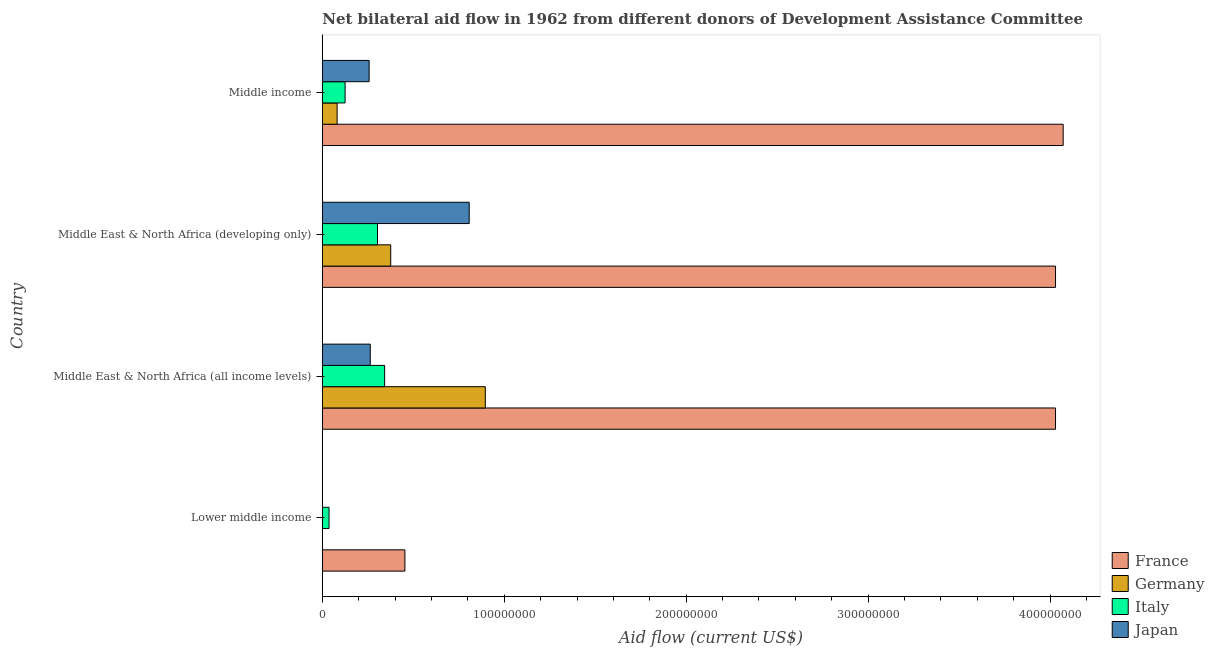How many groups of bars are there?
Keep it short and to the point. 4. Are the number of bars per tick equal to the number of legend labels?
Your answer should be very brief. No. What is the label of the 1st group of bars from the top?
Offer a very short reply. Middle income. In how many cases, is the number of bars for a given country not equal to the number of legend labels?
Make the answer very short. 1. What is the amount of aid given by italy in Lower middle income?
Offer a terse response. 3.69e+06. Across all countries, what is the maximum amount of aid given by germany?
Your response must be concise. 8.96e+07. Across all countries, what is the minimum amount of aid given by germany?
Your answer should be very brief. 8.00e+04. In which country was the amount of aid given by japan maximum?
Make the answer very short. Middle East & North Africa (developing only). What is the total amount of aid given by france in the graph?
Your response must be concise. 1.26e+09. What is the difference between the amount of aid given by germany in Lower middle income and that in Middle income?
Give a very brief answer. -8.05e+06. What is the difference between the amount of aid given by germany in Middle income and the amount of aid given by italy in Middle East & North Africa (all income levels)?
Provide a succinct answer. -2.61e+07. What is the average amount of aid given by france per country?
Make the answer very short. 3.15e+08. What is the difference between the amount of aid given by italy and amount of aid given by germany in Middle East & North Africa (developing only)?
Keep it short and to the point. -7.27e+06. What is the ratio of the amount of aid given by germany in Middle East & North Africa (developing only) to that in Middle income?
Provide a short and direct response. 4.62. Is the amount of aid given by japan in Middle East & North Africa (all income levels) less than that in Middle income?
Make the answer very short. No. What is the difference between the highest and the second highest amount of aid given by italy?
Your answer should be very brief. 3.92e+06. What is the difference between the highest and the lowest amount of aid given by france?
Ensure brevity in your answer.  3.62e+08. Is the sum of the amount of aid given by germany in Middle East & North Africa (all income levels) and Middle East & North Africa (developing only) greater than the maximum amount of aid given by france across all countries?
Provide a short and direct response. No. Is it the case that in every country, the sum of the amount of aid given by japan and amount of aid given by germany is greater than the sum of amount of aid given by france and amount of aid given by italy?
Your answer should be compact. No. Is it the case that in every country, the sum of the amount of aid given by france and amount of aid given by germany is greater than the amount of aid given by italy?
Make the answer very short. Yes. How many countries are there in the graph?
Offer a very short reply. 4. What is the difference between two consecutive major ticks on the X-axis?
Provide a short and direct response. 1.00e+08. Does the graph contain grids?
Make the answer very short. No. Where does the legend appear in the graph?
Ensure brevity in your answer.  Bottom right. How many legend labels are there?
Your answer should be compact. 4. What is the title of the graph?
Your answer should be compact. Net bilateral aid flow in 1962 from different donors of Development Assistance Committee. Does "Bird species" appear as one of the legend labels in the graph?
Offer a very short reply. No. What is the label or title of the X-axis?
Keep it short and to the point. Aid flow (current US$). What is the Aid flow (current US$) of France in Lower middle income?
Your answer should be very brief. 4.54e+07. What is the Aid flow (current US$) of Italy in Lower middle income?
Your answer should be compact. 3.69e+06. What is the Aid flow (current US$) in France in Middle East & North Africa (all income levels)?
Offer a terse response. 4.03e+08. What is the Aid flow (current US$) of Germany in Middle East & North Africa (all income levels)?
Your answer should be compact. 8.96e+07. What is the Aid flow (current US$) in Italy in Middle East & North Africa (all income levels)?
Keep it short and to the point. 3.42e+07. What is the Aid flow (current US$) in Japan in Middle East & North Africa (all income levels)?
Your answer should be very brief. 2.64e+07. What is the Aid flow (current US$) in France in Middle East & North Africa (developing only)?
Make the answer very short. 4.03e+08. What is the Aid flow (current US$) in Germany in Middle East & North Africa (developing only)?
Your response must be concise. 3.76e+07. What is the Aid flow (current US$) of Italy in Middle East & North Africa (developing only)?
Keep it short and to the point. 3.03e+07. What is the Aid flow (current US$) in Japan in Middle East & North Africa (developing only)?
Your answer should be compact. 8.07e+07. What is the Aid flow (current US$) of France in Middle income?
Your answer should be compact. 4.07e+08. What is the Aid flow (current US$) of Germany in Middle income?
Provide a short and direct response. 8.13e+06. What is the Aid flow (current US$) of Italy in Middle income?
Ensure brevity in your answer.  1.25e+07. What is the Aid flow (current US$) of Japan in Middle income?
Your answer should be compact. 2.57e+07. Across all countries, what is the maximum Aid flow (current US$) of France?
Keep it short and to the point. 4.07e+08. Across all countries, what is the maximum Aid flow (current US$) in Germany?
Your response must be concise. 8.96e+07. Across all countries, what is the maximum Aid flow (current US$) in Italy?
Offer a very short reply. 3.42e+07. Across all countries, what is the maximum Aid flow (current US$) of Japan?
Ensure brevity in your answer.  8.07e+07. Across all countries, what is the minimum Aid flow (current US$) in France?
Your response must be concise. 4.54e+07. Across all countries, what is the minimum Aid flow (current US$) in Italy?
Your answer should be very brief. 3.69e+06. What is the total Aid flow (current US$) of France in the graph?
Provide a short and direct response. 1.26e+09. What is the total Aid flow (current US$) in Germany in the graph?
Offer a very short reply. 1.35e+08. What is the total Aid flow (current US$) of Italy in the graph?
Your response must be concise. 8.08e+07. What is the total Aid flow (current US$) in Japan in the graph?
Provide a short and direct response. 1.33e+08. What is the difference between the Aid flow (current US$) in France in Lower middle income and that in Middle East & North Africa (all income levels)?
Ensure brevity in your answer.  -3.58e+08. What is the difference between the Aid flow (current US$) of Germany in Lower middle income and that in Middle East & North Africa (all income levels)?
Provide a succinct answer. -8.95e+07. What is the difference between the Aid flow (current US$) in Italy in Lower middle income and that in Middle East & North Africa (all income levels)?
Offer a terse response. -3.06e+07. What is the difference between the Aid flow (current US$) in France in Lower middle income and that in Middle East & North Africa (developing only)?
Provide a succinct answer. -3.58e+08. What is the difference between the Aid flow (current US$) in Germany in Lower middle income and that in Middle East & North Africa (developing only)?
Make the answer very short. -3.75e+07. What is the difference between the Aid flow (current US$) of Italy in Lower middle income and that in Middle East & North Africa (developing only)?
Ensure brevity in your answer.  -2.66e+07. What is the difference between the Aid flow (current US$) of France in Lower middle income and that in Middle income?
Give a very brief answer. -3.62e+08. What is the difference between the Aid flow (current US$) in Germany in Lower middle income and that in Middle income?
Ensure brevity in your answer.  -8.05e+06. What is the difference between the Aid flow (current US$) of Italy in Lower middle income and that in Middle income?
Give a very brief answer. -8.81e+06. What is the difference between the Aid flow (current US$) of Germany in Middle East & North Africa (all income levels) and that in Middle East & North Africa (developing only)?
Give a very brief answer. 5.20e+07. What is the difference between the Aid flow (current US$) in Italy in Middle East & North Africa (all income levels) and that in Middle East & North Africa (developing only)?
Ensure brevity in your answer.  3.92e+06. What is the difference between the Aid flow (current US$) of Japan in Middle East & North Africa (all income levels) and that in Middle East & North Africa (developing only)?
Your answer should be compact. -5.44e+07. What is the difference between the Aid flow (current US$) of France in Middle East & North Africa (all income levels) and that in Middle income?
Your answer should be very brief. -4.20e+06. What is the difference between the Aid flow (current US$) in Germany in Middle East & North Africa (all income levels) and that in Middle income?
Offer a very short reply. 8.14e+07. What is the difference between the Aid flow (current US$) of Italy in Middle East & North Africa (all income levels) and that in Middle income?
Offer a very short reply. 2.17e+07. What is the difference between the Aid flow (current US$) in Japan in Middle East & North Africa (all income levels) and that in Middle income?
Your answer should be very brief. 6.30e+05. What is the difference between the Aid flow (current US$) in France in Middle East & North Africa (developing only) and that in Middle income?
Offer a terse response. -4.20e+06. What is the difference between the Aid flow (current US$) in Germany in Middle East & North Africa (developing only) and that in Middle income?
Make the answer very short. 2.95e+07. What is the difference between the Aid flow (current US$) of Italy in Middle East & North Africa (developing only) and that in Middle income?
Give a very brief answer. 1.78e+07. What is the difference between the Aid flow (current US$) in Japan in Middle East & North Africa (developing only) and that in Middle income?
Provide a succinct answer. 5.50e+07. What is the difference between the Aid flow (current US$) of France in Lower middle income and the Aid flow (current US$) of Germany in Middle East & North Africa (all income levels)?
Provide a short and direct response. -4.42e+07. What is the difference between the Aid flow (current US$) of France in Lower middle income and the Aid flow (current US$) of Italy in Middle East & North Africa (all income levels)?
Offer a terse response. 1.12e+07. What is the difference between the Aid flow (current US$) of France in Lower middle income and the Aid flow (current US$) of Japan in Middle East & North Africa (all income levels)?
Keep it short and to the point. 1.90e+07. What is the difference between the Aid flow (current US$) in Germany in Lower middle income and the Aid flow (current US$) in Italy in Middle East & North Africa (all income levels)?
Keep it short and to the point. -3.42e+07. What is the difference between the Aid flow (current US$) of Germany in Lower middle income and the Aid flow (current US$) of Japan in Middle East & North Africa (all income levels)?
Provide a short and direct response. -2.63e+07. What is the difference between the Aid flow (current US$) of Italy in Lower middle income and the Aid flow (current US$) of Japan in Middle East & North Africa (all income levels)?
Keep it short and to the point. -2.27e+07. What is the difference between the Aid flow (current US$) of France in Lower middle income and the Aid flow (current US$) of Germany in Middle East & North Africa (developing only)?
Keep it short and to the point. 7.81e+06. What is the difference between the Aid flow (current US$) in France in Lower middle income and the Aid flow (current US$) in Italy in Middle East & North Africa (developing only)?
Offer a very short reply. 1.51e+07. What is the difference between the Aid flow (current US$) in France in Lower middle income and the Aid flow (current US$) in Japan in Middle East & North Africa (developing only)?
Your response must be concise. -3.53e+07. What is the difference between the Aid flow (current US$) of Germany in Lower middle income and the Aid flow (current US$) of Italy in Middle East & North Africa (developing only)?
Ensure brevity in your answer.  -3.02e+07. What is the difference between the Aid flow (current US$) of Germany in Lower middle income and the Aid flow (current US$) of Japan in Middle East & North Africa (developing only)?
Make the answer very short. -8.06e+07. What is the difference between the Aid flow (current US$) in Italy in Lower middle income and the Aid flow (current US$) in Japan in Middle East & North Africa (developing only)?
Ensure brevity in your answer.  -7.70e+07. What is the difference between the Aid flow (current US$) of France in Lower middle income and the Aid flow (current US$) of Germany in Middle income?
Provide a succinct answer. 3.73e+07. What is the difference between the Aid flow (current US$) of France in Lower middle income and the Aid flow (current US$) of Italy in Middle income?
Give a very brief answer. 3.29e+07. What is the difference between the Aid flow (current US$) of France in Lower middle income and the Aid flow (current US$) of Japan in Middle income?
Offer a terse response. 1.97e+07. What is the difference between the Aid flow (current US$) of Germany in Lower middle income and the Aid flow (current US$) of Italy in Middle income?
Keep it short and to the point. -1.24e+07. What is the difference between the Aid flow (current US$) of Germany in Lower middle income and the Aid flow (current US$) of Japan in Middle income?
Your answer should be compact. -2.56e+07. What is the difference between the Aid flow (current US$) in Italy in Lower middle income and the Aid flow (current US$) in Japan in Middle income?
Offer a very short reply. -2.20e+07. What is the difference between the Aid flow (current US$) of France in Middle East & North Africa (all income levels) and the Aid flow (current US$) of Germany in Middle East & North Africa (developing only)?
Keep it short and to the point. 3.65e+08. What is the difference between the Aid flow (current US$) of France in Middle East & North Africa (all income levels) and the Aid flow (current US$) of Italy in Middle East & North Africa (developing only)?
Provide a short and direct response. 3.73e+08. What is the difference between the Aid flow (current US$) in France in Middle East & North Africa (all income levels) and the Aid flow (current US$) in Japan in Middle East & North Africa (developing only)?
Give a very brief answer. 3.22e+08. What is the difference between the Aid flow (current US$) of Germany in Middle East & North Africa (all income levels) and the Aid flow (current US$) of Italy in Middle East & North Africa (developing only)?
Offer a very short reply. 5.93e+07. What is the difference between the Aid flow (current US$) of Germany in Middle East & North Africa (all income levels) and the Aid flow (current US$) of Japan in Middle East & North Africa (developing only)?
Make the answer very short. 8.85e+06. What is the difference between the Aid flow (current US$) of Italy in Middle East & North Africa (all income levels) and the Aid flow (current US$) of Japan in Middle East & North Africa (developing only)?
Your response must be concise. -4.65e+07. What is the difference between the Aid flow (current US$) of France in Middle East & North Africa (all income levels) and the Aid flow (current US$) of Germany in Middle income?
Give a very brief answer. 3.95e+08. What is the difference between the Aid flow (current US$) of France in Middle East & North Africa (all income levels) and the Aid flow (current US$) of Italy in Middle income?
Your answer should be compact. 3.90e+08. What is the difference between the Aid flow (current US$) of France in Middle East & North Africa (all income levels) and the Aid flow (current US$) of Japan in Middle income?
Keep it short and to the point. 3.77e+08. What is the difference between the Aid flow (current US$) of Germany in Middle East & North Africa (all income levels) and the Aid flow (current US$) of Italy in Middle income?
Keep it short and to the point. 7.71e+07. What is the difference between the Aid flow (current US$) of Germany in Middle East & North Africa (all income levels) and the Aid flow (current US$) of Japan in Middle income?
Provide a succinct answer. 6.39e+07. What is the difference between the Aid flow (current US$) in Italy in Middle East & North Africa (all income levels) and the Aid flow (current US$) in Japan in Middle income?
Your response must be concise. 8.52e+06. What is the difference between the Aid flow (current US$) of France in Middle East & North Africa (developing only) and the Aid flow (current US$) of Germany in Middle income?
Provide a short and direct response. 3.95e+08. What is the difference between the Aid flow (current US$) in France in Middle East & North Africa (developing only) and the Aid flow (current US$) in Italy in Middle income?
Offer a terse response. 3.90e+08. What is the difference between the Aid flow (current US$) of France in Middle East & North Africa (developing only) and the Aid flow (current US$) of Japan in Middle income?
Your answer should be compact. 3.77e+08. What is the difference between the Aid flow (current US$) in Germany in Middle East & North Africa (developing only) and the Aid flow (current US$) in Italy in Middle income?
Provide a short and direct response. 2.51e+07. What is the difference between the Aid flow (current US$) of Germany in Middle East & North Africa (developing only) and the Aid flow (current US$) of Japan in Middle income?
Provide a succinct answer. 1.19e+07. What is the difference between the Aid flow (current US$) in Italy in Middle East & North Africa (developing only) and the Aid flow (current US$) in Japan in Middle income?
Give a very brief answer. 4.60e+06. What is the average Aid flow (current US$) of France per country?
Offer a very short reply. 3.15e+08. What is the average Aid flow (current US$) in Germany per country?
Keep it short and to the point. 3.38e+07. What is the average Aid flow (current US$) of Italy per country?
Your answer should be compact. 2.02e+07. What is the average Aid flow (current US$) of Japan per country?
Your answer should be compact. 3.32e+07. What is the difference between the Aid flow (current US$) of France and Aid flow (current US$) of Germany in Lower middle income?
Make the answer very short. 4.53e+07. What is the difference between the Aid flow (current US$) in France and Aid flow (current US$) in Italy in Lower middle income?
Provide a short and direct response. 4.17e+07. What is the difference between the Aid flow (current US$) of Germany and Aid flow (current US$) of Italy in Lower middle income?
Make the answer very short. -3.61e+06. What is the difference between the Aid flow (current US$) in France and Aid flow (current US$) in Germany in Middle East & North Africa (all income levels)?
Keep it short and to the point. 3.13e+08. What is the difference between the Aid flow (current US$) in France and Aid flow (current US$) in Italy in Middle East & North Africa (all income levels)?
Offer a very short reply. 3.69e+08. What is the difference between the Aid flow (current US$) in France and Aid flow (current US$) in Japan in Middle East & North Africa (all income levels)?
Provide a short and direct response. 3.77e+08. What is the difference between the Aid flow (current US$) of Germany and Aid flow (current US$) of Italy in Middle East & North Africa (all income levels)?
Your answer should be very brief. 5.53e+07. What is the difference between the Aid flow (current US$) of Germany and Aid flow (current US$) of Japan in Middle East & North Africa (all income levels)?
Your answer should be very brief. 6.32e+07. What is the difference between the Aid flow (current US$) of Italy and Aid flow (current US$) of Japan in Middle East & North Africa (all income levels)?
Your answer should be very brief. 7.89e+06. What is the difference between the Aid flow (current US$) in France and Aid flow (current US$) in Germany in Middle East & North Africa (developing only)?
Give a very brief answer. 3.65e+08. What is the difference between the Aid flow (current US$) of France and Aid flow (current US$) of Italy in Middle East & North Africa (developing only)?
Provide a succinct answer. 3.73e+08. What is the difference between the Aid flow (current US$) in France and Aid flow (current US$) in Japan in Middle East & North Africa (developing only)?
Give a very brief answer. 3.22e+08. What is the difference between the Aid flow (current US$) of Germany and Aid flow (current US$) of Italy in Middle East & North Africa (developing only)?
Offer a very short reply. 7.27e+06. What is the difference between the Aid flow (current US$) in Germany and Aid flow (current US$) in Japan in Middle East & North Africa (developing only)?
Ensure brevity in your answer.  -4.31e+07. What is the difference between the Aid flow (current US$) of Italy and Aid flow (current US$) of Japan in Middle East & North Africa (developing only)?
Ensure brevity in your answer.  -5.04e+07. What is the difference between the Aid flow (current US$) in France and Aid flow (current US$) in Germany in Middle income?
Ensure brevity in your answer.  3.99e+08. What is the difference between the Aid flow (current US$) of France and Aid flow (current US$) of Italy in Middle income?
Your answer should be very brief. 3.95e+08. What is the difference between the Aid flow (current US$) of France and Aid flow (current US$) of Japan in Middle income?
Your answer should be compact. 3.81e+08. What is the difference between the Aid flow (current US$) in Germany and Aid flow (current US$) in Italy in Middle income?
Make the answer very short. -4.37e+06. What is the difference between the Aid flow (current US$) in Germany and Aid flow (current US$) in Japan in Middle income?
Keep it short and to the point. -1.76e+07. What is the difference between the Aid flow (current US$) of Italy and Aid flow (current US$) of Japan in Middle income?
Give a very brief answer. -1.32e+07. What is the ratio of the Aid flow (current US$) of France in Lower middle income to that in Middle East & North Africa (all income levels)?
Offer a terse response. 0.11. What is the ratio of the Aid flow (current US$) of Germany in Lower middle income to that in Middle East & North Africa (all income levels)?
Provide a short and direct response. 0. What is the ratio of the Aid flow (current US$) in Italy in Lower middle income to that in Middle East & North Africa (all income levels)?
Offer a very short reply. 0.11. What is the ratio of the Aid flow (current US$) in France in Lower middle income to that in Middle East & North Africa (developing only)?
Make the answer very short. 0.11. What is the ratio of the Aid flow (current US$) of Germany in Lower middle income to that in Middle East & North Africa (developing only)?
Offer a very short reply. 0. What is the ratio of the Aid flow (current US$) in Italy in Lower middle income to that in Middle East & North Africa (developing only)?
Provide a succinct answer. 0.12. What is the ratio of the Aid flow (current US$) in France in Lower middle income to that in Middle income?
Provide a short and direct response. 0.11. What is the ratio of the Aid flow (current US$) of Germany in Lower middle income to that in Middle income?
Your answer should be compact. 0.01. What is the ratio of the Aid flow (current US$) of Italy in Lower middle income to that in Middle income?
Your answer should be compact. 0.3. What is the ratio of the Aid flow (current US$) of Germany in Middle East & North Africa (all income levels) to that in Middle East & North Africa (developing only)?
Make the answer very short. 2.38. What is the ratio of the Aid flow (current US$) in Italy in Middle East & North Africa (all income levels) to that in Middle East & North Africa (developing only)?
Ensure brevity in your answer.  1.13. What is the ratio of the Aid flow (current US$) in Japan in Middle East & North Africa (all income levels) to that in Middle East & North Africa (developing only)?
Keep it short and to the point. 0.33. What is the ratio of the Aid flow (current US$) of Germany in Middle East & North Africa (all income levels) to that in Middle income?
Ensure brevity in your answer.  11.02. What is the ratio of the Aid flow (current US$) in Italy in Middle East & North Africa (all income levels) to that in Middle income?
Your answer should be compact. 2.74. What is the ratio of the Aid flow (current US$) in Japan in Middle East & North Africa (all income levels) to that in Middle income?
Provide a short and direct response. 1.02. What is the ratio of the Aid flow (current US$) of France in Middle East & North Africa (developing only) to that in Middle income?
Keep it short and to the point. 0.99. What is the ratio of the Aid flow (current US$) in Germany in Middle East & North Africa (developing only) to that in Middle income?
Your response must be concise. 4.62. What is the ratio of the Aid flow (current US$) in Italy in Middle East & North Africa (developing only) to that in Middle income?
Ensure brevity in your answer.  2.43. What is the ratio of the Aid flow (current US$) in Japan in Middle East & North Africa (developing only) to that in Middle income?
Offer a terse response. 3.14. What is the difference between the highest and the second highest Aid flow (current US$) in France?
Keep it short and to the point. 4.20e+06. What is the difference between the highest and the second highest Aid flow (current US$) of Germany?
Offer a terse response. 5.20e+07. What is the difference between the highest and the second highest Aid flow (current US$) of Italy?
Your answer should be compact. 3.92e+06. What is the difference between the highest and the second highest Aid flow (current US$) of Japan?
Provide a short and direct response. 5.44e+07. What is the difference between the highest and the lowest Aid flow (current US$) in France?
Offer a very short reply. 3.62e+08. What is the difference between the highest and the lowest Aid flow (current US$) in Germany?
Keep it short and to the point. 8.95e+07. What is the difference between the highest and the lowest Aid flow (current US$) of Italy?
Make the answer very short. 3.06e+07. What is the difference between the highest and the lowest Aid flow (current US$) in Japan?
Ensure brevity in your answer.  8.07e+07. 